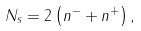Convert formula to latex. <formula><loc_0><loc_0><loc_500><loc_500>N _ { s } = 2 \left ( n ^ { - } + n ^ { + } \right ) ,</formula> 